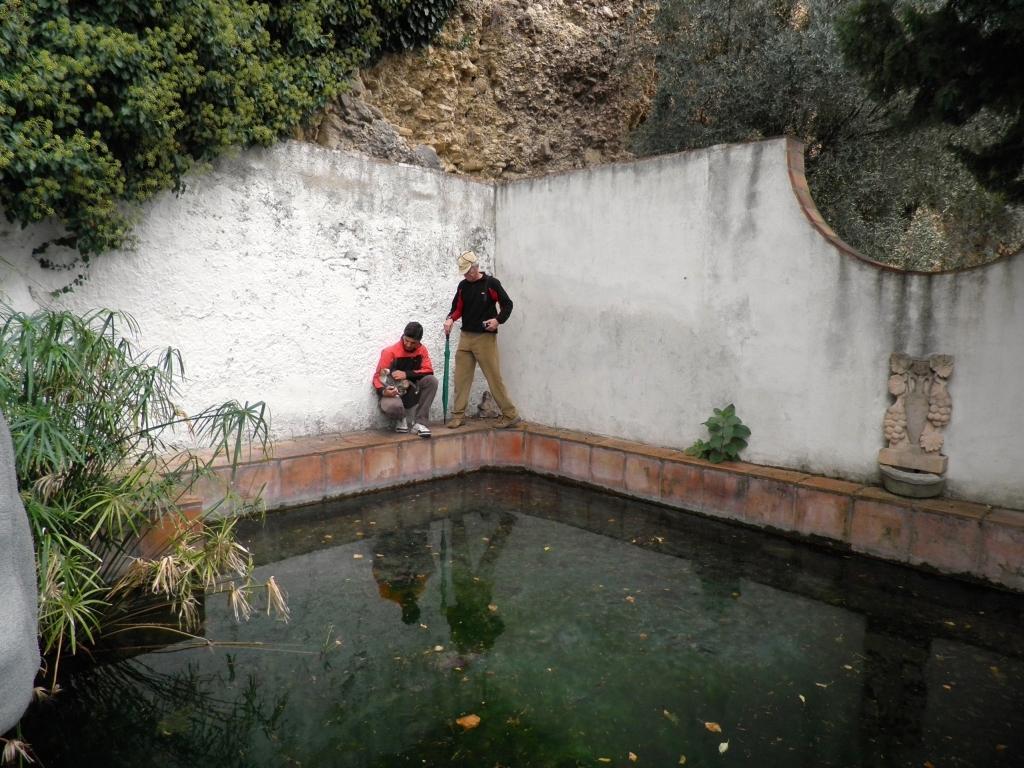In one or two sentences, can you explain what this image depicts? In this image we can see a pond with a sidewall. On the sidewall two persons are there. One person is wearing a cap and holding an umbrella. Also there is a plant. In the back there are trees. And there is a statue on the wall. 